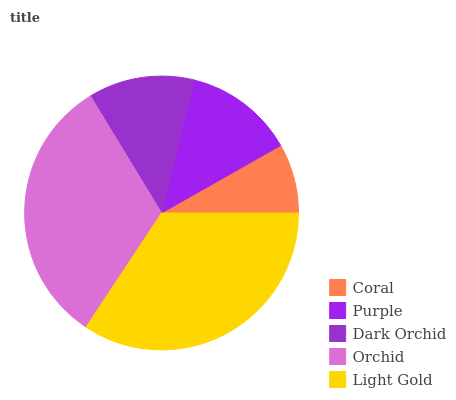Is Coral the minimum?
Answer yes or no. Yes. Is Light Gold the maximum?
Answer yes or no. Yes. Is Purple the minimum?
Answer yes or no. No. Is Purple the maximum?
Answer yes or no. No. Is Purple greater than Coral?
Answer yes or no. Yes. Is Coral less than Purple?
Answer yes or no. Yes. Is Coral greater than Purple?
Answer yes or no. No. Is Purple less than Coral?
Answer yes or no. No. Is Purple the high median?
Answer yes or no. Yes. Is Purple the low median?
Answer yes or no. Yes. Is Coral the high median?
Answer yes or no. No. Is Light Gold the low median?
Answer yes or no. No. 